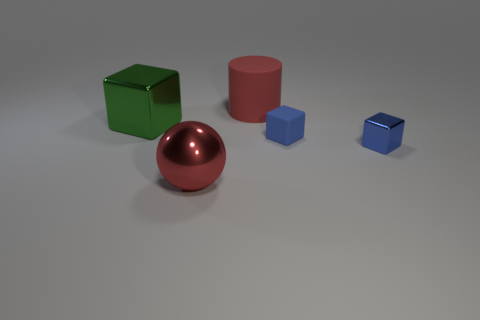How many other things are the same color as the large metal block?
Ensure brevity in your answer.  0. Do the blue rubber block and the green metal cube have the same size?
Provide a short and direct response. No. How many cubes are big metallic objects or big green objects?
Offer a very short reply. 1. How many cubes are both on the left side of the big red cylinder and to the right of the red metallic sphere?
Offer a very short reply. 0. Does the green metallic block have the same size as the thing that is behind the green object?
Offer a very short reply. Yes. There is a large metallic thing behind the metal block in front of the green cube; are there any small blue matte blocks that are to the left of it?
Ensure brevity in your answer.  No. There is a big red object that is in front of the big thing that is right of the large red shiny thing; what is its material?
Keep it short and to the point. Metal. What material is the thing that is both in front of the blue rubber cube and on the left side of the small blue matte thing?
Provide a succinct answer. Metal. Are there any other green shiny things that have the same shape as the small metal thing?
Offer a terse response. Yes. Is there a small cube behind the rubber object right of the large matte object?
Ensure brevity in your answer.  No. 